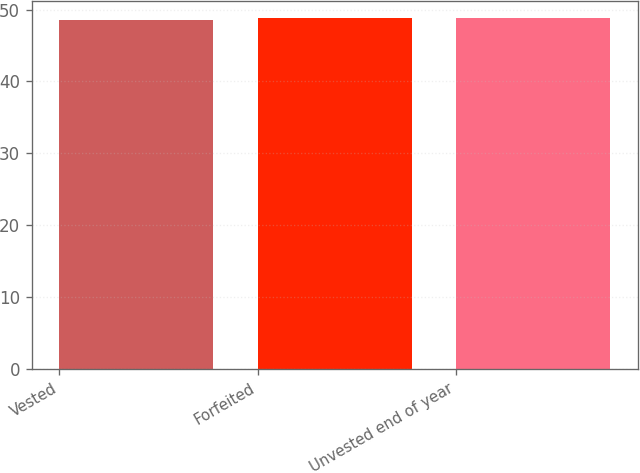Convert chart to OTSL. <chart><loc_0><loc_0><loc_500><loc_500><bar_chart><fcel>Vested<fcel>Forfeited<fcel>Unvested end of year<nl><fcel>48.56<fcel>48.78<fcel>48.82<nl></chart> 